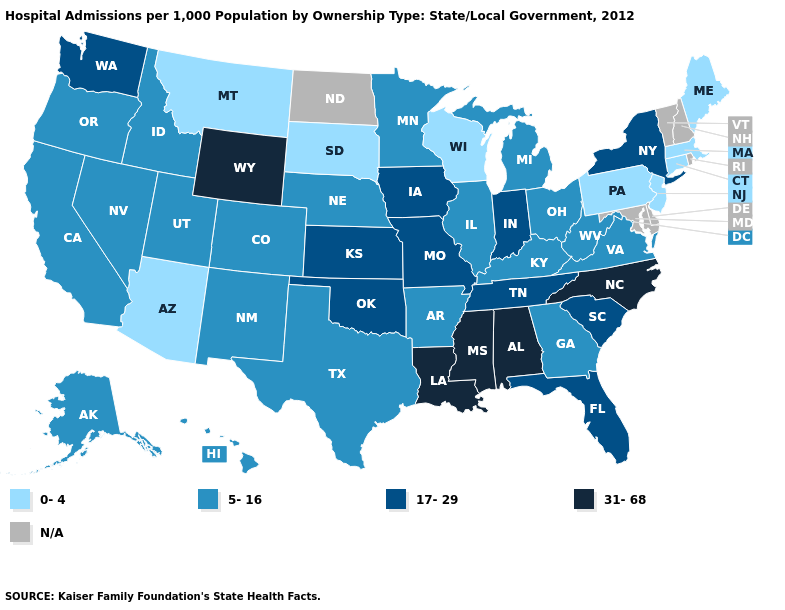What is the lowest value in the USA?
Answer briefly. 0-4. What is the highest value in states that border Minnesota?
Give a very brief answer. 17-29. How many symbols are there in the legend?
Short answer required. 5. What is the highest value in the USA?
Short answer required. 31-68. Name the states that have a value in the range 5-16?
Write a very short answer. Alaska, Arkansas, California, Colorado, Georgia, Hawaii, Idaho, Illinois, Kentucky, Michigan, Minnesota, Nebraska, Nevada, New Mexico, Ohio, Oregon, Texas, Utah, Virginia, West Virginia. Does Washington have the lowest value in the West?
Answer briefly. No. What is the value of Arkansas?
Quick response, please. 5-16. What is the highest value in states that border North Carolina?
Keep it brief. 17-29. What is the lowest value in states that border Ohio?
Answer briefly. 0-4. Does Alabama have the highest value in the USA?
Quick response, please. Yes. Does Arkansas have the lowest value in the South?
Answer briefly. Yes. What is the lowest value in states that border Arizona?
Keep it brief. 5-16. Name the states that have a value in the range 31-68?
Be succinct. Alabama, Louisiana, Mississippi, North Carolina, Wyoming. Name the states that have a value in the range 0-4?
Short answer required. Arizona, Connecticut, Maine, Massachusetts, Montana, New Jersey, Pennsylvania, South Dakota, Wisconsin. Does North Carolina have the highest value in the USA?
Quick response, please. Yes. 